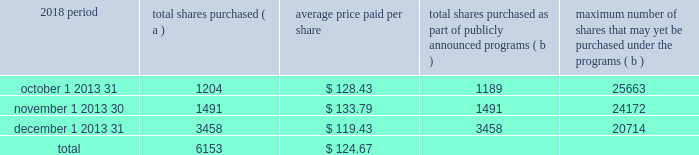The pnc financial services group , inc .
2013 form 10-k 29 part ii item 5 2013 market for registrant 2019s common equity , related stockholder matters and issuer purchases of equity securities ( a ) ( 1 ) our common stock is listed on the new york stock exchange and is traded under the symbol 201cpnc . 201d at the close of business on february 15 , 2019 , there were 53986 common shareholders of record .
Holders of pnc common stock are entitled to receive dividends when declared by our board of directors out of funds legally available for this purpose .
Our board of directors may not pay or set apart dividends on the common stock until dividends for all past dividend periods on any series of outstanding preferred stock and certain outstanding capital securities issued by the parent company have been paid or declared and set apart for payment .
The board of directors presently intends to continue the policy of paying quarterly cash dividends .
The amount of any future dividends will depend on economic and market conditions , our financial condition and operating results , and other factors , including contractual restrictions and applicable government regulations and policies ( such as those relating to the ability of bank and non-bank subsidiaries to pay dividends to the parent company and regulatory capital limitations ) .
The amount of our dividend is also currently subject to the results of the supervisory assessment of capital adequacy and capital planning processes undertaken by the federal reserve and our primary bank regulators as part of the comprehensive capital analysis and review ( ccar ) process as described in the supervision and regulation section in item 1 of this report .
The federal reserve has the power to prohibit us from paying dividends without its approval .
For further information concerning dividend restrictions and other factors that could limit our ability to pay dividends , as well as restrictions on loans , dividends or advances from bank subsidiaries to the parent company , see the supervision and regulation section in item 1 , item 1a risk factors , the liquidity and capital management portion of the risk management section in item 7 , and note 10 borrowed funds , note 15 equity and note 18 regulatory matters in the notes to consolidated financial statements in item 8 of this report , which we include here by reference .
We include here by reference the information regarding our compensation plans under which pnc equity securities are authorized for issuance as of december 31 , 2018 in the table ( with introductory paragraph and notes ) in item 12 of this report .
Our stock transfer agent and registrar is : computershare trust company , n.a .
250 royall street canton , ma 02021 800-982-7652 www.computershare.com/pnc registered shareholders may contact computershare regarding dividends and other shareholder services .
We include here by reference the information that appears under the common stock performance graph caption at the end of this item 5 .
( a ) ( 2 ) none .
( b ) not applicable .
( c ) details of our repurchases of pnc common stock during the fourth quarter of 2018 are included in the table : in thousands , except per share data 2018 period total shares purchased ( a ) average price paid per share total shares purchased as part of publicly announced programs ( b ) maximum number of shares that may yet be purchased under the programs ( b ) .
( a ) includes pnc common stock purchased in connection with our various employee benefit plans generally related to forfeitures of unvested restricted stock awards and shares used to cover employee payroll tax withholding requirements .
Note 11 employee benefit plans and note 12 stock based compensation plans in the notes to consolidated financial statements in item 8 of this report include additional information regarding our employee benefit and equity compensation plans that use pnc common stock .
( b ) on march 11 , 2015 , we announced that our board of directors approved a stock repurchase program authorization in the amount of 100 million shares of pnc common stock , effective april 1 , 2015 .
Repurchases are made in open market or privately negotiated transactions and the timing and exact amount of common stock repurchases will depend on a number of factors including , among others , market and general economic conditions , regulatory capital considerations , alternative uses of capital , the potential impact on our credit ratings , and contractual and regulatory limitations , including the results of the supervisory assessment of capital adequacy and capital planning processes undertaken by the federal reserve as part of the ccar process .
In june 2018 , we announced share repurchase programs of up to $ 2.0 billion for the four quarter period beginning with the third quarter of 2018 , including repurchases of up to $ 300 million related to stock issuances under employee benefit plans , in accordance with pnc's 2018 capital plan .
In november 2018 , we announced an increase to these previously announced programs in the amount of up to $ 900 million in additional common share repurchases .
The aggregate repurchase price of shares repurchased during the fourth quarter of 2018 was $ .8 billion .
See the liquidity and capital management portion of the risk management section in item 7 of this report for more information on the authorized share repurchase programs for the period july 1 , 2018 through june 30 , 2019 .
Http://www.computershare.com/pnc .
In october , 2018 , what was the total amount spent on purchased shares? 
Computations: (1204 * 128.43)
Answer: 154629.72. 